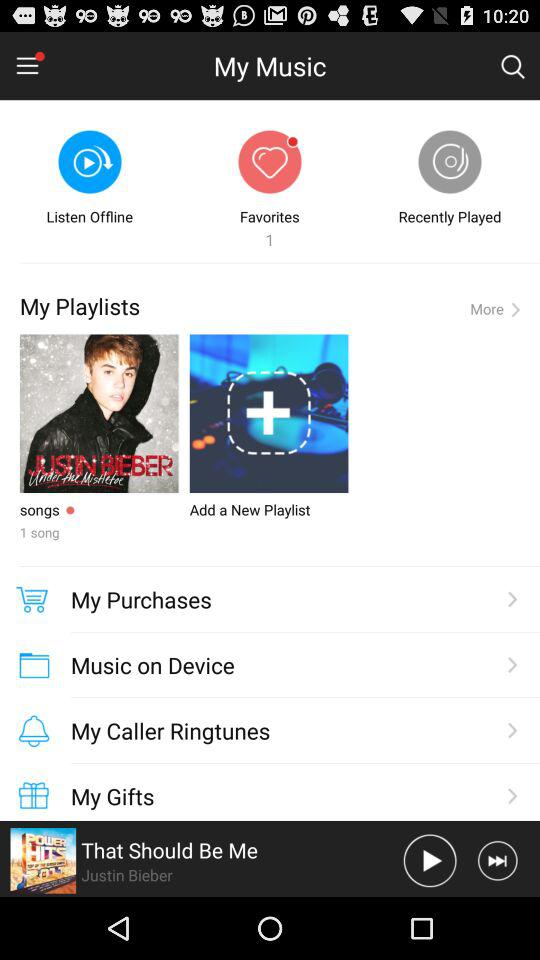Who sing's the song "That Should Be Me"? The song is sung by Justin Bieber. 